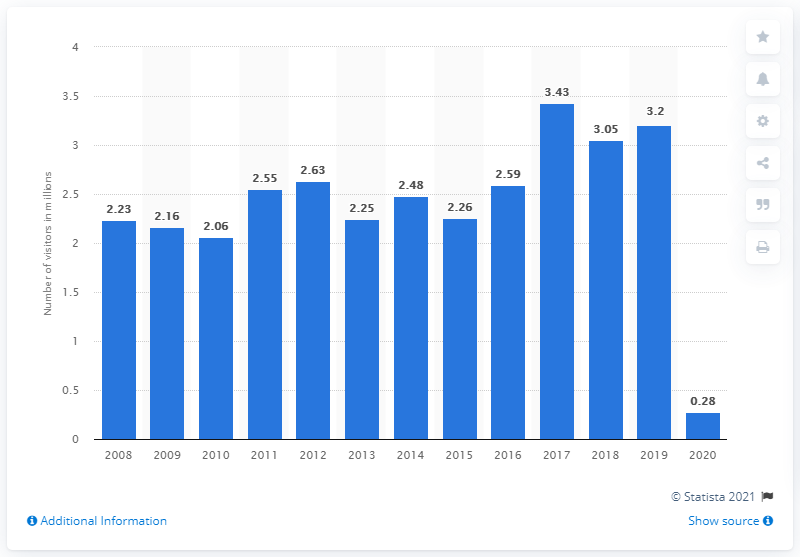Indicate a few pertinent items in this graphic. In 2019, there were 3.2 visitors to Boston National Historical Park. 